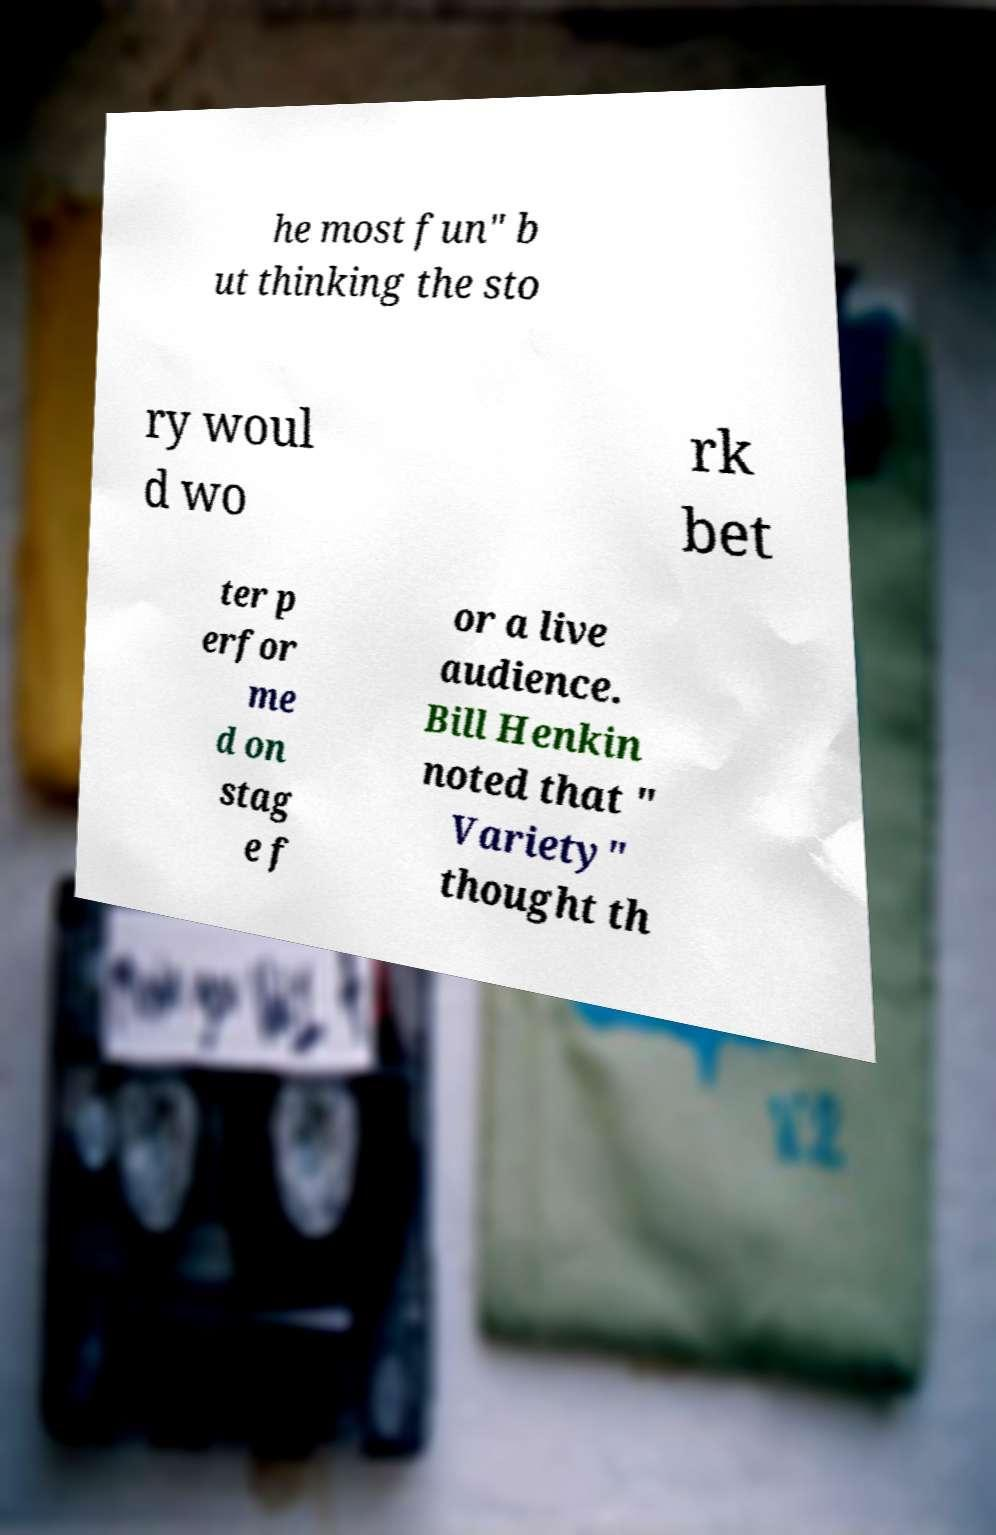Could you extract and type out the text from this image? he most fun" b ut thinking the sto ry woul d wo rk bet ter p erfor me d on stag e f or a live audience. Bill Henkin noted that " Variety" thought th 